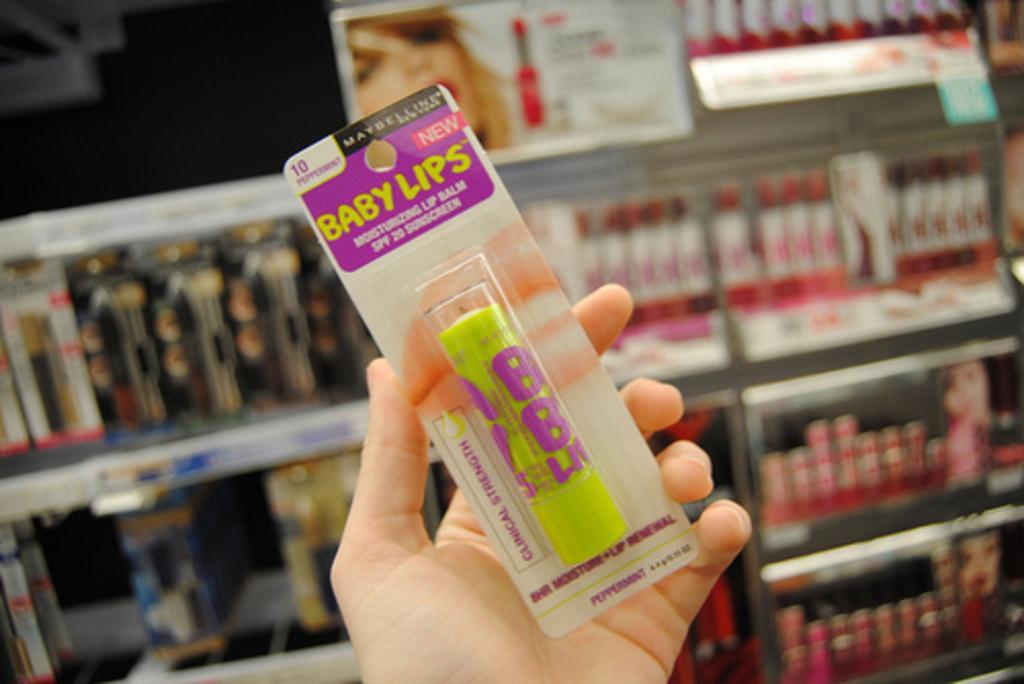In one or two sentences, can you explain what this image depicts? In this image we can see a human hand holding an object and it seems like there are some objects kept in the racks in the background. 